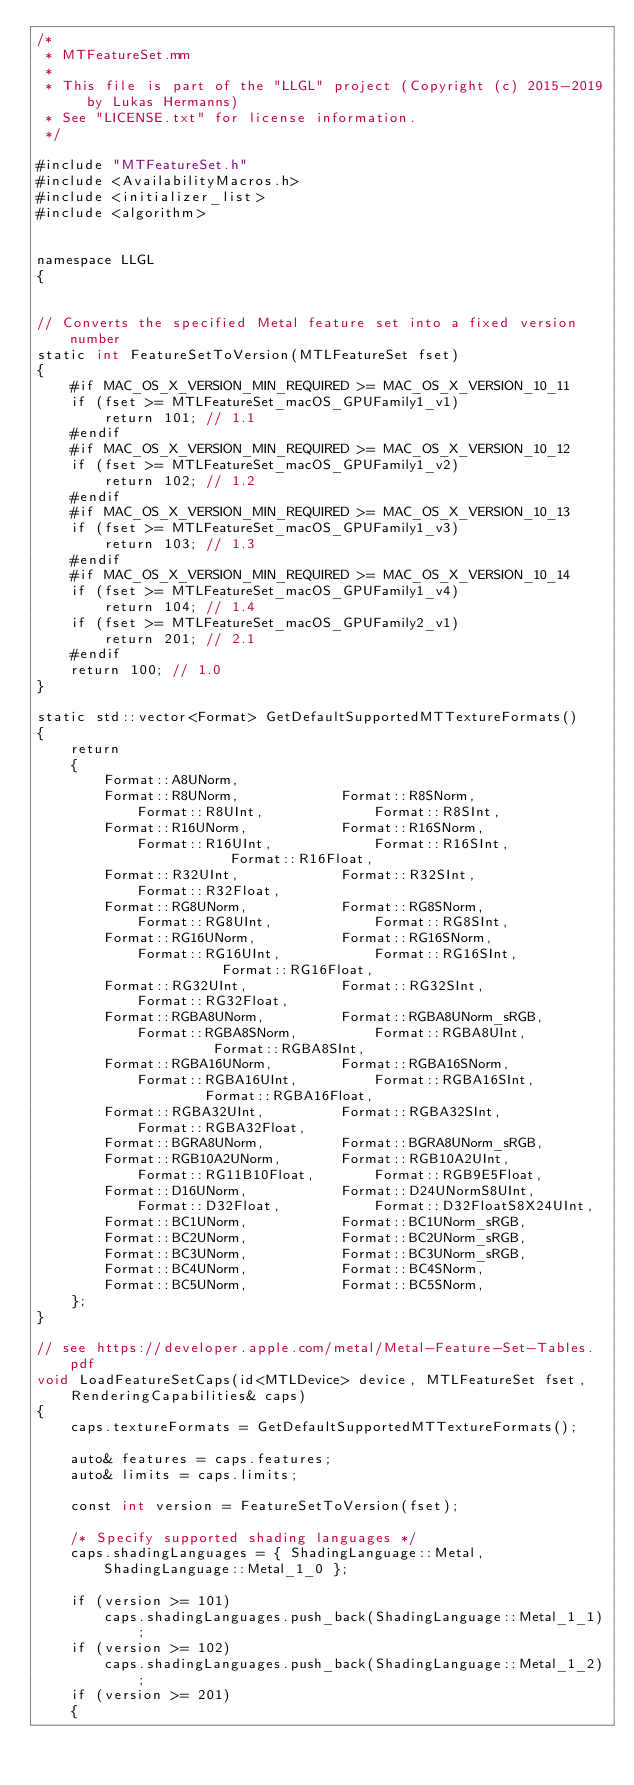Convert code to text. <code><loc_0><loc_0><loc_500><loc_500><_ObjectiveC_>/*
 * MTFeatureSet.mm
 * 
 * This file is part of the "LLGL" project (Copyright (c) 2015-2019 by Lukas Hermanns)
 * See "LICENSE.txt" for license information.
 */

#include "MTFeatureSet.h"
#include <AvailabilityMacros.h>
#include <initializer_list>
#include <algorithm>


namespace LLGL
{


// Converts the specified Metal feature set into a fixed version number
static int FeatureSetToVersion(MTLFeatureSet fset)
{
    #if MAC_OS_X_VERSION_MIN_REQUIRED >= MAC_OS_X_VERSION_10_11
    if (fset >= MTLFeatureSet_macOS_GPUFamily1_v1)
        return 101; // 1.1
    #endif
    #if MAC_OS_X_VERSION_MIN_REQUIRED >= MAC_OS_X_VERSION_10_12
    if (fset >= MTLFeatureSet_macOS_GPUFamily1_v2)
        return 102; // 1.2
    #endif
    #if MAC_OS_X_VERSION_MIN_REQUIRED >= MAC_OS_X_VERSION_10_13
    if (fset >= MTLFeatureSet_macOS_GPUFamily1_v3)
        return 103; // 1.3
    #endif
    #if MAC_OS_X_VERSION_MIN_REQUIRED >= MAC_OS_X_VERSION_10_14
    if (fset >= MTLFeatureSet_macOS_GPUFamily1_v4)
        return 104; // 1.4
    if (fset >= MTLFeatureSet_macOS_GPUFamily2_v1)
        return 201; // 2.1
    #endif
    return 100; // 1.0
}

static std::vector<Format> GetDefaultSupportedMTTextureFormats()
{
    return
    {
        Format::A8UNorm,
        Format::R8UNorm,            Format::R8SNorm,            Format::R8UInt,             Format::R8SInt,
        Format::R16UNorm,           Format::R16SNorm,           Format::R16UInt,            Format::R16SInt,            Format::R16Float,
        Format::R32UInt,            Format::R32SInt,            Format::R32Float,
        Format::RG8UNorm,           Format::RG8SNorm,           Format::RG8UInt,            Format::RG8SInt,
        Format::RG16UNorm,          Format::RG16SNorm,          Format::RG16UInt,           Format::RG16SInt,           Format::RG16Float,
        Format::RG32UInt,           Format::RG32SInt,           Format::RG32Float,
        Format::RGBA8UNorm,         Format::RGBA8UNorm_sRGB,    Format::RGBA8SNorm,         Format::RGBA8UInt,          Format::RGBA8SInt,
        Format::RGBA16UNorm,        Format::RGBA16SNorm,        Format::RGBA16UInt,         Format::RGBA16SInt,         Format::RGBA16Float,
        Format::RGBA32UInt,         Format::RGBA32SInt,         Format::RGBA32Float,
        Format::BGRA8UNorm,         Format::BGRA8UNorm_sRGB,
        Format::RGB10A2UNorm,       Format::RGB10A2UInt,        Format::RG11B10Float,       Format::RGB9E5Float,
        Format::D16UNorm,           Format::D24UNormS8UInt,     Format::D32Float,           Format::D32FloatS8X24UInt,
        Format::BC1UNorm,           Format::BC1UNorm_sRGB,
        Format::BC2UNorm,           Format::BC2UNorm_sRGB,
        Format::BC3UNorm,           Format::BC3UNorm_sRGB,
        Format::BC4UNorm,           Format::BC4SNorm,
        Format::BC5UNorm,           Format::BC5SNorm,
    };
}

// see https://developer.apple.com/metal/Metal-Feature-Set-Tables.pdf
void LoadFeatureSetCaps(id<MTLDevice> device, MTLFeatureSet fset, RenderingCapabilities& caps)
{
    caps.textureFormats = GetDefaultSupportedMTTextureFormats();

    auto& features = caps.features;
    auto& limits = caps.limits;

    const int version = FeatureSetToVersion(fset);

    /* Specify supported shading languages */
    caps.shadingLanguages = { ShadingLanguage::Metal, ShadingLanguage::Metal_1_0 };

    if (version >= 101)
        caps.shadingLanguages.push_back(ShadingLanguage::Metal_1_1);
    if (version >= 102)
        caps.shadingLanguages.push_back(ShadingLanguage::Metal_1_2);
    if (version >= 201)
    {</code> 